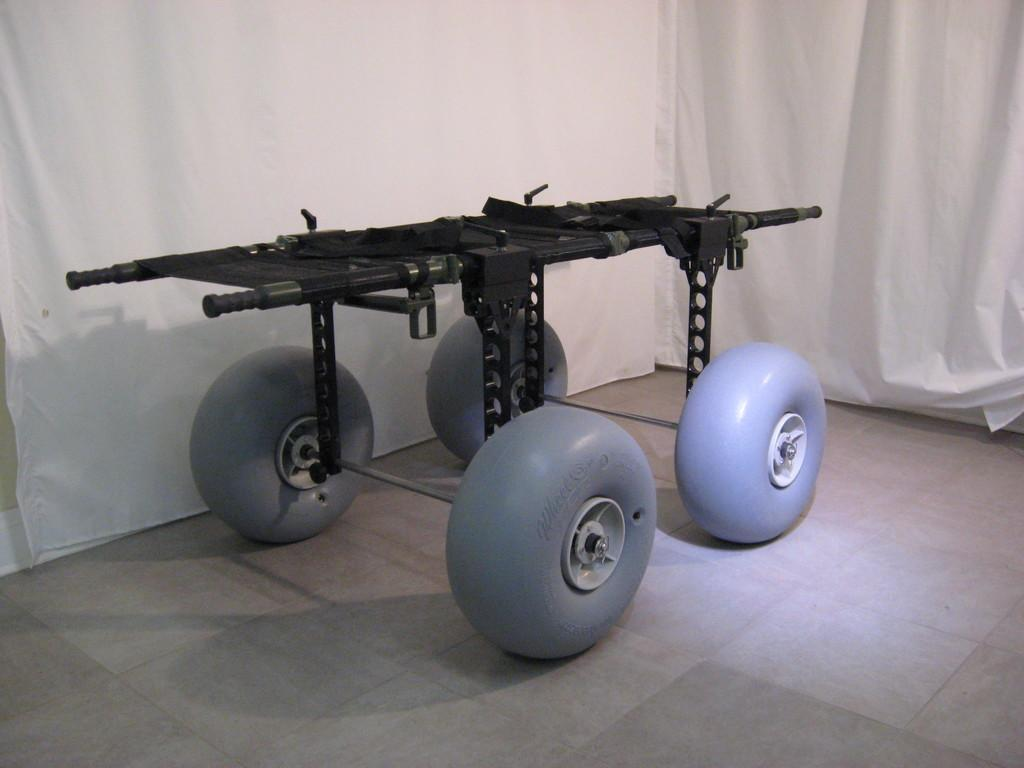What is the main subject in the middle of the image? There is a rover robot in the middle of the image. What can be seen in the background of the image? There are white color curtains in the background of the image. What type of meat is being served for breakfast in the image? There is no meat or breakfast present in the image; it features a rover robot and white color curtains. 